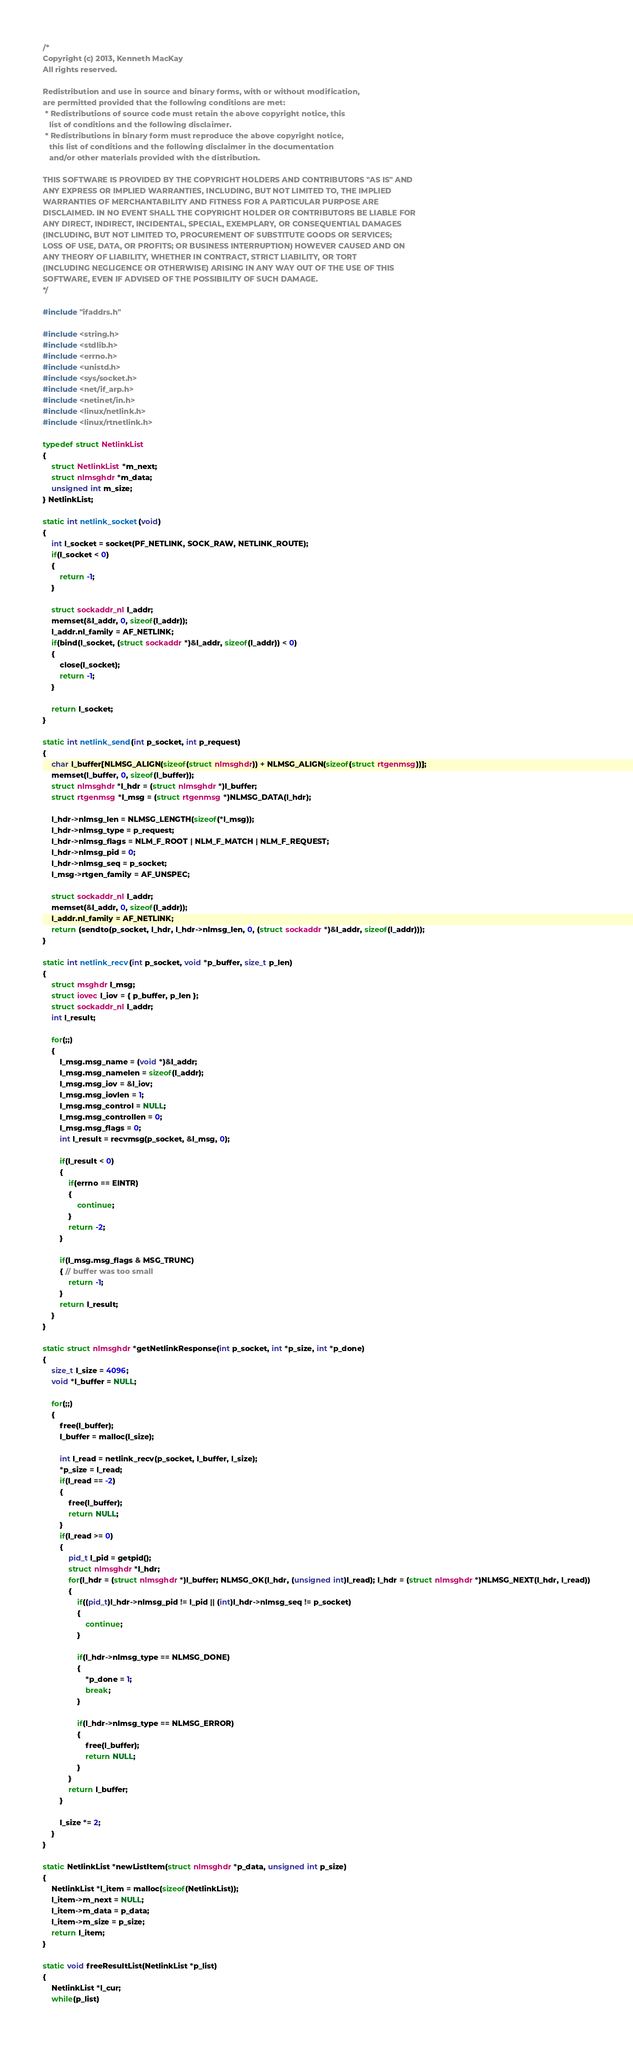<code> <loc_0><loc_0><loc_500><loc_500><_C_>/*
Copyright (c) 2013, Kenneth MacKay
All rights reserved.

Redistribution and use in source and binary forms, with or without modification,
are permitted provided that the following conditions are met:
 * Redistributions of source code must retain the above copyright notice, this
   list of conditions and the following disclaimer.
 * Redistributions in binary form must reproduce the above copyright notice,
   this list of conditions and the following disclaimer in the documentation
   and/or other materials provided with the distribution.

THIS SOFTWARE IS PROVIDED BY THE COPYRIGHT HOLDERS AND CONTRIBUTORS "AS IS" AND
ANY EXPRESS OR IMPLIED WARRANTIES, INCLUDING, BUT NOT LIMITED TO, THE IMPLIED
WARRANTIES OF MERCHANTABILITY AND FITNESS FOR A PARTICULAR PURPOSE ARE
DISCLAIMED. IN NO EVENT SHALL THE COPYRIGHT HOLDER OR CONTRIBUTORS BE LIABLE FOR
ANY DIRECT, INDIRECT, INCIDENTAL, SPECIAL, EXEMPLARY, OR CONSEQUENTIAL DAMAGES
(INCLUDING, BUT NOT LIMITED TO, PROCUREMENT OF SUBSTITUTE GOODS OR SERVICES;
LOSS OF USE, DATA, OR PROFITS; OR BUSINESS INTERRUPTION) HOWEVER CAUSED AND ON
ANY THEORY OF LIABILITY, WHETHER IN CONTRACT, STRICT LIABILITY, OR TORT
(INCLUDING NEGLIGENCE OR OTHERWISE) ARISING IN ANY WAY OUT OF THE USE OF THIS
SOFTWARE, EVEN IF ADVISED OF THE POSSIBILITY OF SUCH DAMAGE.
*/

#include "ifaddrs.h"

#include <string.h>
#include <stdlib.h>
#include <errno.h>
#include <unistd.h>
#include <sys/socket.h>
#include <net/if_arp.h>
#include <netinet/in.h>
#include <linux/netlink.h>
#include <linux/rtnetlink.h>

typedef struct NetlinkList
{
    struct NetlinkList *m_next;
    struct nlmsghdr *m_data;
    unsigned int m_size;
} NetlinkList;

static int netlink_socket(void)
{
    int l_socket = socket(PF_NETLINK, SOCK_RAW, NETLINK_ROUTE);
    if(l_socket < 0)
    {
        return -1;
    }
    
    struct sockaddr_nl l_addr;
    memset(&l_addr, 0, sizeof(l_addr));
    l_addr.nl_family = AF_NETLINK;
    if(bind(l_socket, (struct sockaddr *)&l_addr, sizeof(l_addr)) < 0)
    {
        close(l_socket);
        return -1;
    }
    
    return l_socket;
}

static int netlink_send(int p_socket, int p_request)
{
    char l_buffer[NLMSG_ALIGN(sizeof(struct nlmsghdr)) + NLMSG_ALIGN(sizeof(struct rtgenmsg))];
    memset(l_buffer, 0, sizeof(l_buffer));
    struct nlmsghdr *l_hdr = (struct nlmsghdr *)l_buffer;
    struct rtgenmsg *l_msg = (struct rtgenmsg *)NLMSG_DATA(l_hdr);
    
    l_hdr->nlmsg_len = NLMSG_LENGTH(sizeof(*l_msg));
    l_hdr->nlmsg_type = p_request;
    l_hdr->nlmsg_flags = NLM_F_ROOT | NLM_F_MATCH | NLM_F_REQUEST;
    l_hdr->nlmsg_pid = 0;
    l_hdr->nlmsg_seq = p_socket;
    l_msg->rtgen_family = AF_UNSPEC;
    
    struct sockaddr_nl l_addr;
    memset(&l_addr, 0, sizeof(l_addr));
    l_addr.nl_family = AF_NETLINK;
    return (sendto(p_socket, l_hdr, l_hdr->nlmsg_len, 0, (struct sockaddr *)&l_addr, sizeof(l_addr)));
}

static int netlink_recv(int p_socket, void *p_buffer, size_t p_len)
{
    struct msghdr l_msg;
    struct iovec l_iov = { p_buffer, p_len };
    struct sockaddr_nl l_addr;
    int l_result;

    for(;;)
    {
        l_msg.msg_name = (void *)&l_addr;
        l_msg.msg_namelen = sizeof(l_addr);
        l_msg.msg_iov = &l_iov;
        l_msg.msg_iovlen = 1;
        l_msg.msg_control = NULL;
        l_msg.msg_controllen = 0;
        l_msg.msg_flags = 0;
        int l_result = recvmsg(p_socket, &l_msg, 0);
        
        if(l_result < 0)
        {
            if(errno == EINTR)
            {
                continue;
            }
            return -2;
        }
        
        if(l_msg.msg_flags & MSG_TRUNC)
        { // buffer was too small
            return -1;
        }
        return l_result;
    }
}

static struct nlmsghdr *getNetlinkResponse(int p_socket, int *p_size, int *p_done)
{
    size_t l_size = 4096;
    void *l_buffer = NULL;
    
    for(;;)
    {
        free(l_buffer);
        l_buffer = malloc(l_size);
        
        int l_read = netlink_recv(p_socket, l_buffer, l_size);
        *p_size = l_read;
        if(l_read == -2)
        {
            free(l_buffer);
            return NULL;
        }
        if(l_read >= 0)
        {
            pid_t l_pid = getpid();
            struct nlmsghdr *l_hdr;
            for(l_hdr = (struct nlmsghdr *)l_buffer; NLMSG_OK(l_hdr, (unsigned int)l_read); l_hdr = (struct nlmsghdr *)NLMSG_NEXT(l_hdr, l_read))
            {
                if((pid_t)l_hdr->nlmsg_pid != l_pid || (int)l_hdr->nlmsg_seq != p_socket)
                {
                    continue;
                }
                
                if(l_hdr->nlmsg_type == NLMSG_DONE)
                {
                    *p_done = 1;
                    break;
                }
                
                if(l_hdr->nlmsg_type == NLMSG_ERROR)
                {
                    free(l_buffer);
                    return NULL;
                }
            }
            return l_buffer;
        }
        
        l_size *= 2;
    }
}

static NetlinkList *newListItem(struct nlmsghdr *p_data, unsigned int p_size)
{
    NetlinkList *l_item = malloc(sizeof(NetlinkList));
    l_item->m_next = NULL;
    l_item->m_data = p_data;
    l_item->m_size = p_size;
    return l_item;
}

static void freeResultList(NetlinkList *p_list)
{
    NetlinkList *l_cur;
    while(p_list)</code> 